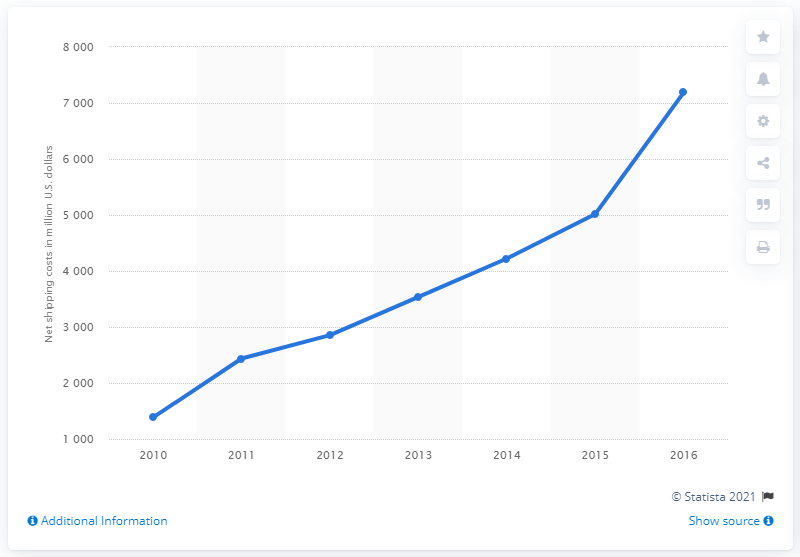Give some essential details in this illustration. In 2016, Amazon's net shipping costs were 7,191. 